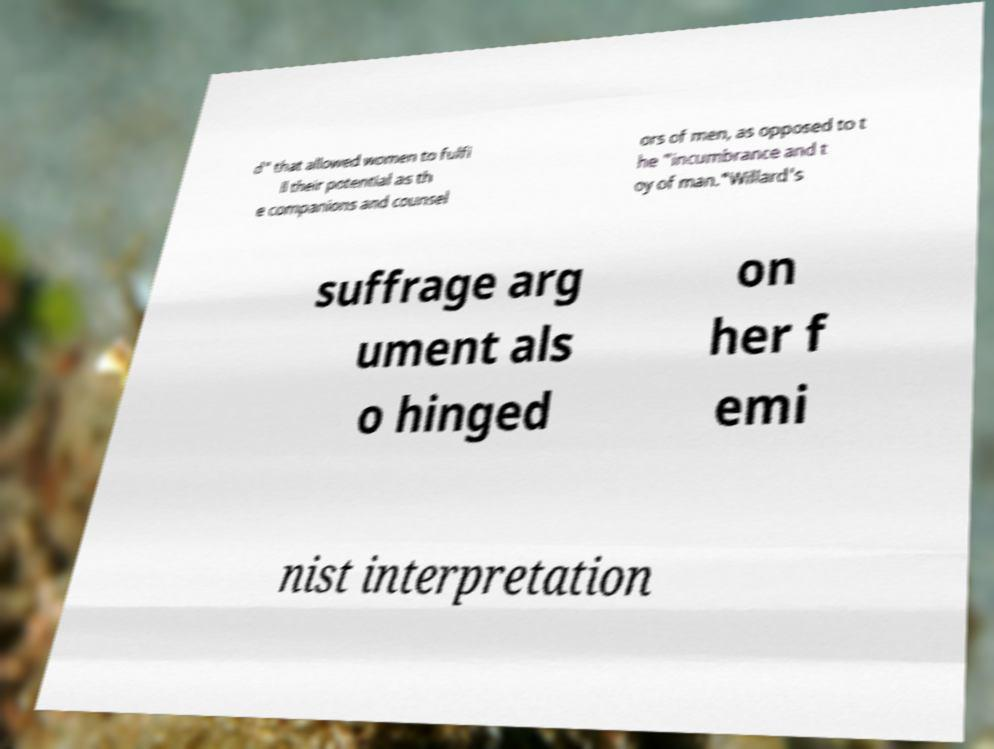Please read and relay the text visible in this image. What does it say? d" that allowed women to fulfi ll their potential as th e companions and counsel ors of men, as opposed to t he "incumbrance and t oy of man."Willard's suffrage arg ument als o hinged on her f emi nist interpretation 